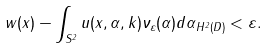<formula> <loc_0><loc_0><loc_500><loc_500>\| w ( x ) - \int _ { S ^ { 2 } } u ( x , \alpha , k ) \nu _ { \varepsilon } ( \alpha ) d \alpha \| _ { H ^ { 2 } ( D ) } < \varepsilon .</formula> 